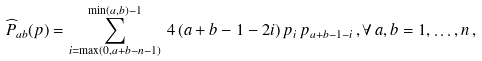Convert formula to latex. <formula><loc_0><loc_0><loc_500><loc_500>{ \widehat { P } } _ { a b } ( p ) = \sum _ { i = \max ( 0 , a + b - n - 1 ) } ^ { \min ( a , b ) - 1 } \, 4 \, ( a + b - 1 - 2 i ) \, p _ { i } \, p _ { a + b - 1 - i } \, , \forall \, a , b = 1 , \dots , n \, ,</formula> 